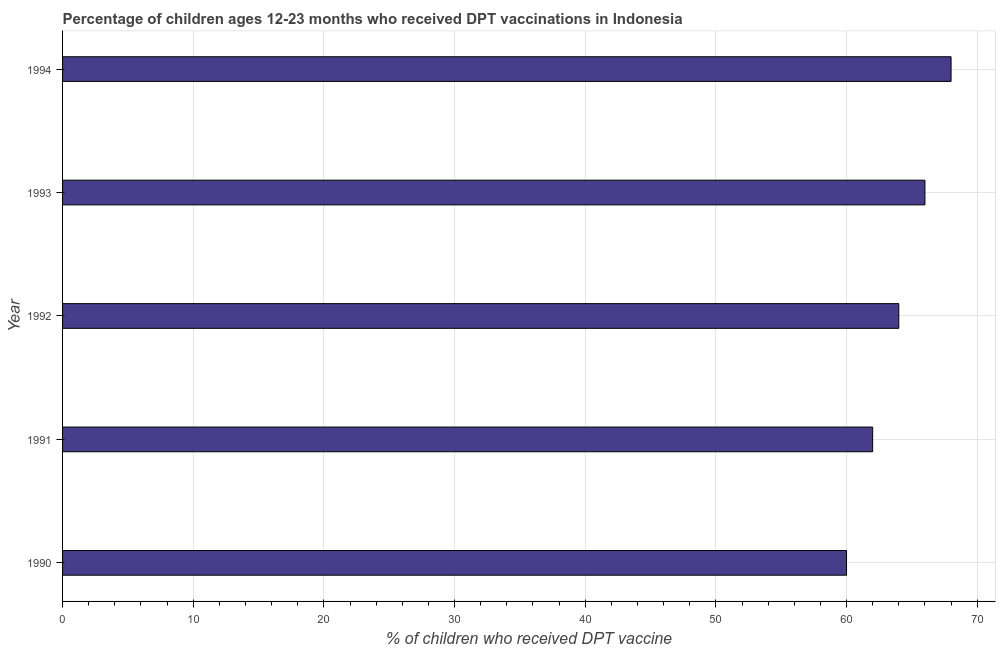Does the graph contain any zero values?
Make the answer very short. No. Does the graph contain grids?
Your answer should be very brief. Yes. What is the title of the graph?
Provide a succinct answer. Percentage of children ages 12-23 months who received DPT vaccinations in Indonesia. What is the label or title of the X-axis?
Your response must be concise. % of children who received DPT vaccine. What is the label or title of the Y-axis?
Keep it short and to the point. Year. What is the percentage of children who received dpt vaccine in 1990?
Offer a terse response. 60. In which year was the percentage of children who received dpt vaccine maximum?
Provide a succinct answer. 1994. What is the sum of the percentage of children who received dpt vaccine?
Make the answer very short. 320. What is the average percentage of children who received dpt vaccine per year?
Your answer should be compact. 64. In how many years, is the percentage of children who received dpt vaccine greater than 54 %?
Keep it short and to the point. 5. What is the ratio of the percentage of children who received dpt vaccine in 1990 to that in 1992?
Give a very brief answer. 0.94. Is the percentage of children who received dpt vaccine in 1990 less than that in 1991?
Keep it short and to the point. Yes. Is the difference between the percentage of children who received dpt vaccine in 1992 and 1994 greater than the difference between any two years?
Offer a terse response. No. What is the difference between the highest and the second highest percentage of children who received dpt vaccine?
Keep it short and to the point. 2. Is the sum of the percentage of children who received dpt vaccine in 1990 and 1994 greater than the maximum percentage of children who received dpt vaccine across all years?
Your answer should be very brief. Yes. What is the difference between the highest and the lowest percentage of children who received dpt vaccine?
Ensure brevity in your answer.  8. In how many years, is the percentage of children who received dpt vaccine greater than the average percentage of children who received dpt vaccine taken over all years?
Keep it short and to the point. 2. How many bars are there?
Provide a short and direct response. 5. What is the difference between two consecutive major ticks on the X-axis?
Make the answer very short. 10. What is the % of children who received DPT vaccine in 1991?
Your answer should be very brief. 62. What is the % of children who received DPT vaccine in 1993?
Your answer should be very brief. 66. What is the % of children who received DPT vaccine of 1994?
Keep it short and to the point. 68. What is the difference between the % of children who received DPT vaccine in 1990 and 1991?
Your answer should be very brief. -2. What is the difference between the % of children who received DPT vaccine in 1990 and 1992?
Provide a short and direct response. -4. What is the difference between the % of children who received DPT vaccine in 1990 and 1993?
Offer a terse response. -6. What is the difference between the % of children who received DPT vaccine in 1991 and 1992?
Ensure brevity in your answer.  -2. What is the difference between the % of children who received DPT vaccine in 1991 and 1994?
Your answer should be compact. -6. What is the difference between the % of children who received DPT vaccine in 1992 and 1994?
Ensure brevity in your answer.  -4. What is the ratio of the % of children who received DPT vaccine in 1990 to that in 1992?
Offer a very short reply. 0.94. What is the ratio of the % of children who received DPT vaccine in 1990 to that in 1993?
Give a very brief answer. 0.91. What is the ratio of the % of children who received DPT vaccine in 1990 to that in 1994?
Keep it short and to the point. 0.88. What is the ratio of the % of children who received DPT vaccine in 1991 to that in 1992?
Ensure brevity in your answer.  0.97. What is the ratio of the % of children who received DPT vaccine in 1991 to that in 1993?
Your response must be concise. 0.94. What is the ratio of the % of children who received DPT vaccine in 1991 to that in 1994?
Ensure brevity in your answer.  0.91. What is the ratio of the % of children who received DPT vaccine in 1992 to that in 1994?
Your answer should be very brief. 0.94. What is the ratio of the % of children who received DPT vaccine in 1993 to that in 1994?
Provide a short and direct response. 0.97. 